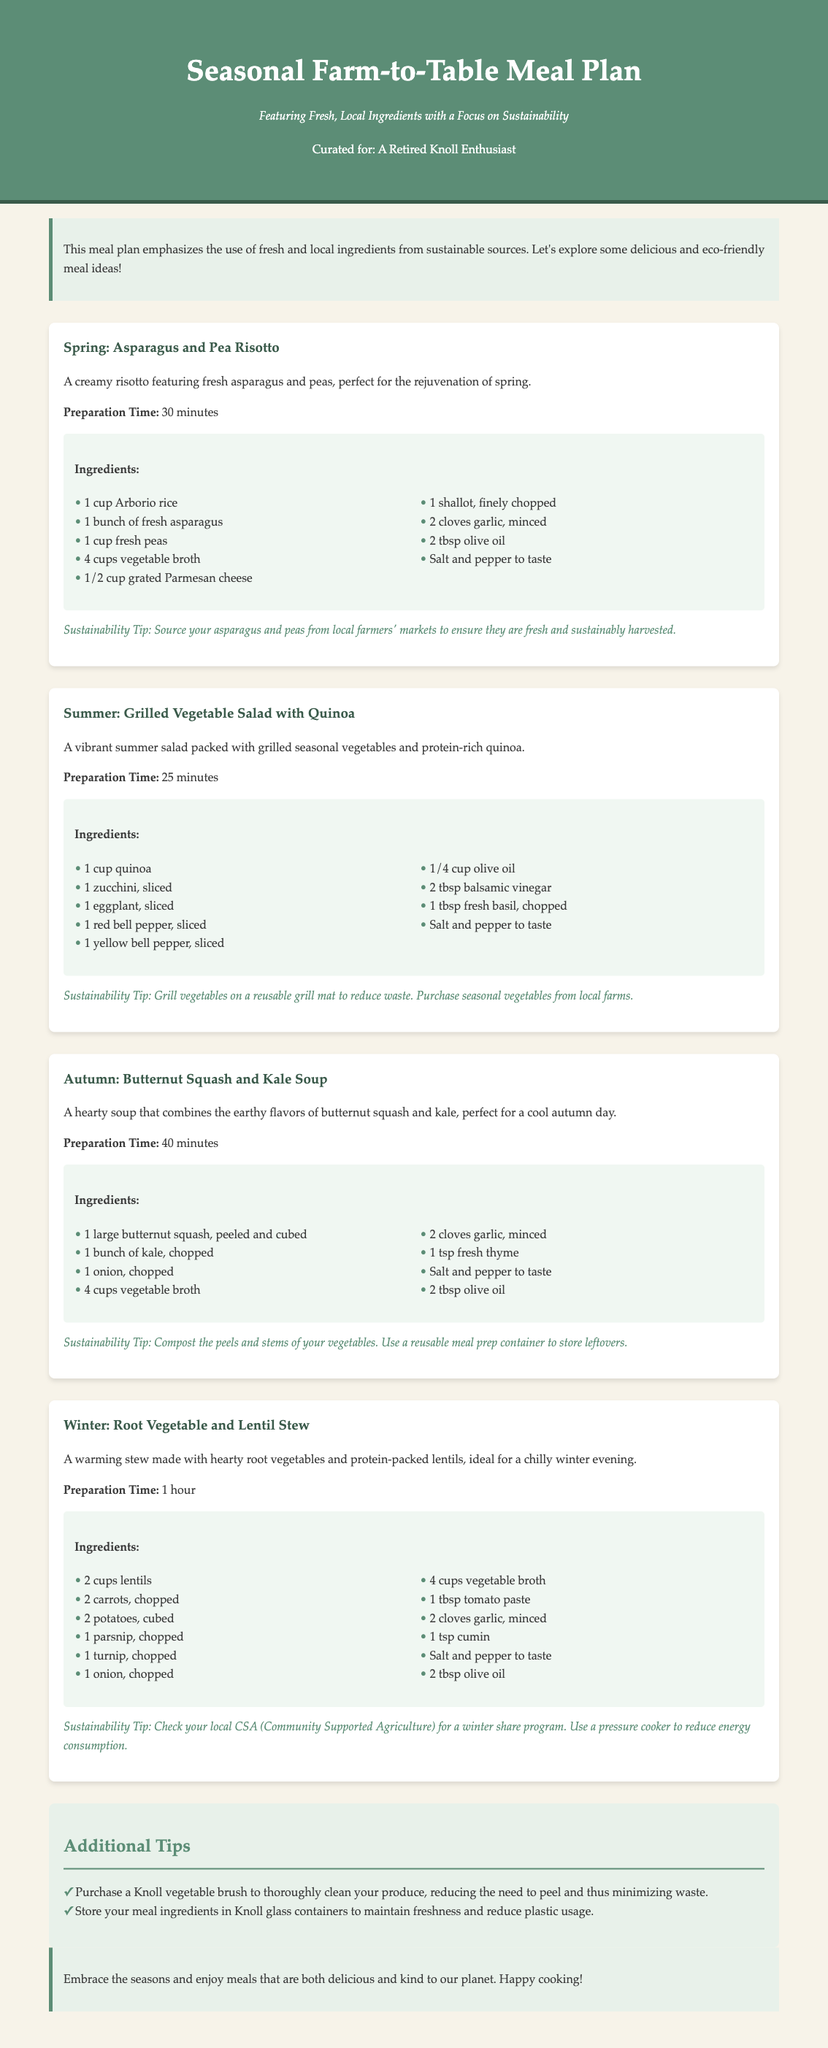What is the title of the meal plan? The title of the meal plan is prominently displayed at the top of the document.
Answer: Seasonal Farm-to-Table Meal Plan What season is the Asparagus and Pea Risotto featured? The meal plan categorizes dishes by seasons, and this dish is listed under spring.
Answer: Spring How many cups of vegetable broth are needed for the Butternut Squash and Kale Soup? The ingredients list for the soup specifies the amount of vegetable broth required.
Answer: 4 cups What is the preparation time for the Root Vegetable and Lentil Stew? The document states the preparation time for each meal, specifically for this stew.
Answer: 1 hour What sustainability tip is given for the Grilled Vegetable Salad with Quinoa? Each meal includes sustainability tips, and this one highlights a specific practice for the salad.
Answer: Grill vegetables on a reusable grill mat How many ingredients are listed for the Summer meal? Counting the ingredients provided for the grilled vegetable salad identifies the total number of ingredients.
Answer: 9 What container is suggested for storing meal ingredients? The additional tips section suggests a specific type of container for storage.
Answer: Knoll glass containers What dish is described as perfect for a cool autumn day? The seasonal meal descriptions indicate which dish is suitable for autumn weather.
Answer: Butternut Squash and Kale Soup What should you do with the peels and stems of vegetables? The sustainability tip for the autumn soup provides a recommendation for dealing with vegetable scraps.
Answer: Compost them 